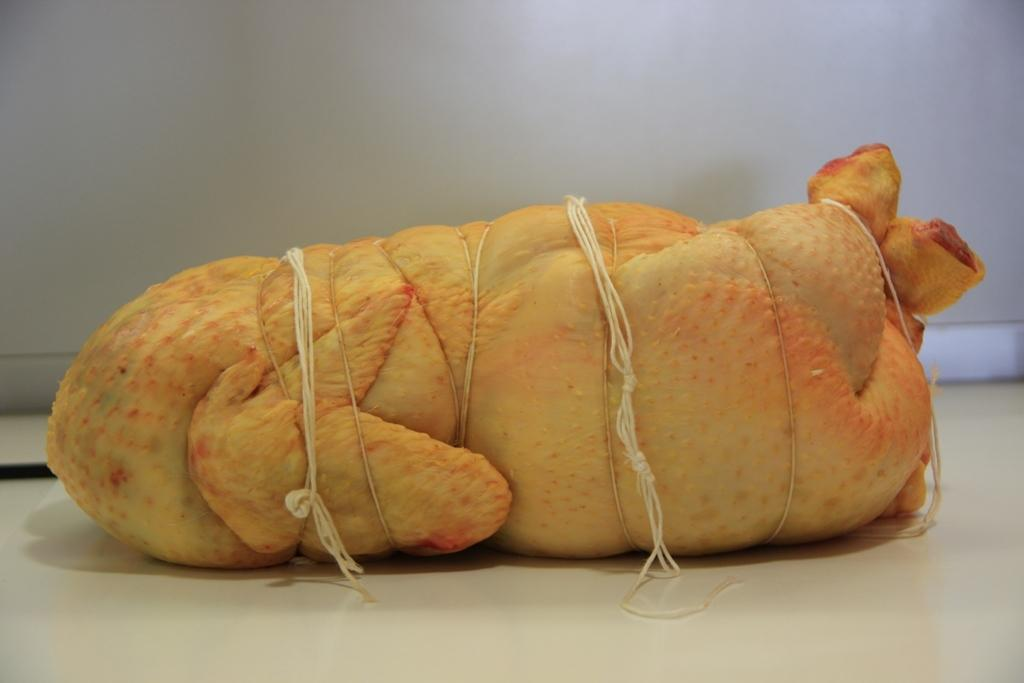What type of food is visible in the image? There is meat in the image. How is the meat prepared or presented? The meat is tied with threads. What color is the background of the image? The background of the image is white. How many women are in jail in the image? There are no women or jails present in the image; it features meat tied with threads against a white background. 